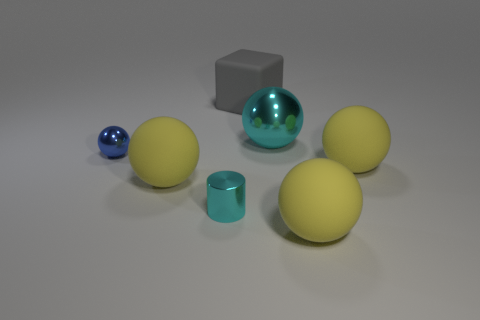How many objects are there in total? There are six objects in total: one cyan metallic sphere, one smaller blue sphere, one gray cube, and three yellow spheres. 